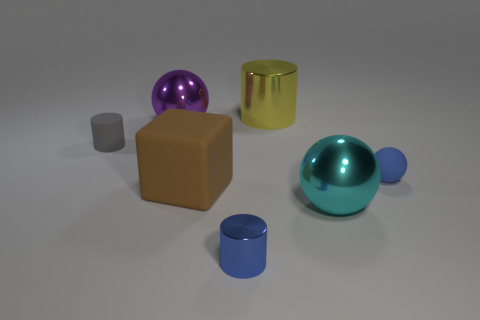Add 2 big purple spheres. How many objects exist? 9 Subtract all cylinders. How many objects are left? 4 Subtract all tiny red rubber cylinders. Subtract all brown objects. How many objects are left? 6 Add 2 rubber balls. How many rubber balls are left? 3 Add 5 yellow balls. How many yellow balls exist? 5 Subtract 0 brown balls. How many objects are left? 7 